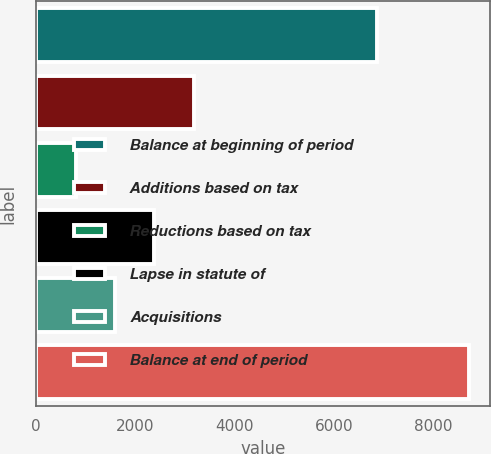<chart> <loc_0><loc_0><loc_500><loc_500><bar_chart><fcel>Balance at beginning of period<fcel>Additions based on tax<fcel>Reductions based on tax<fcel>Lapse in statute of<fcel>Acquisitions<fcel>Balance at end of period<nl><fcel>6859<fcel>3172.5<fcel>801<fcel>2382<fcel>1591.5<fcel>8706<nl></chart> 